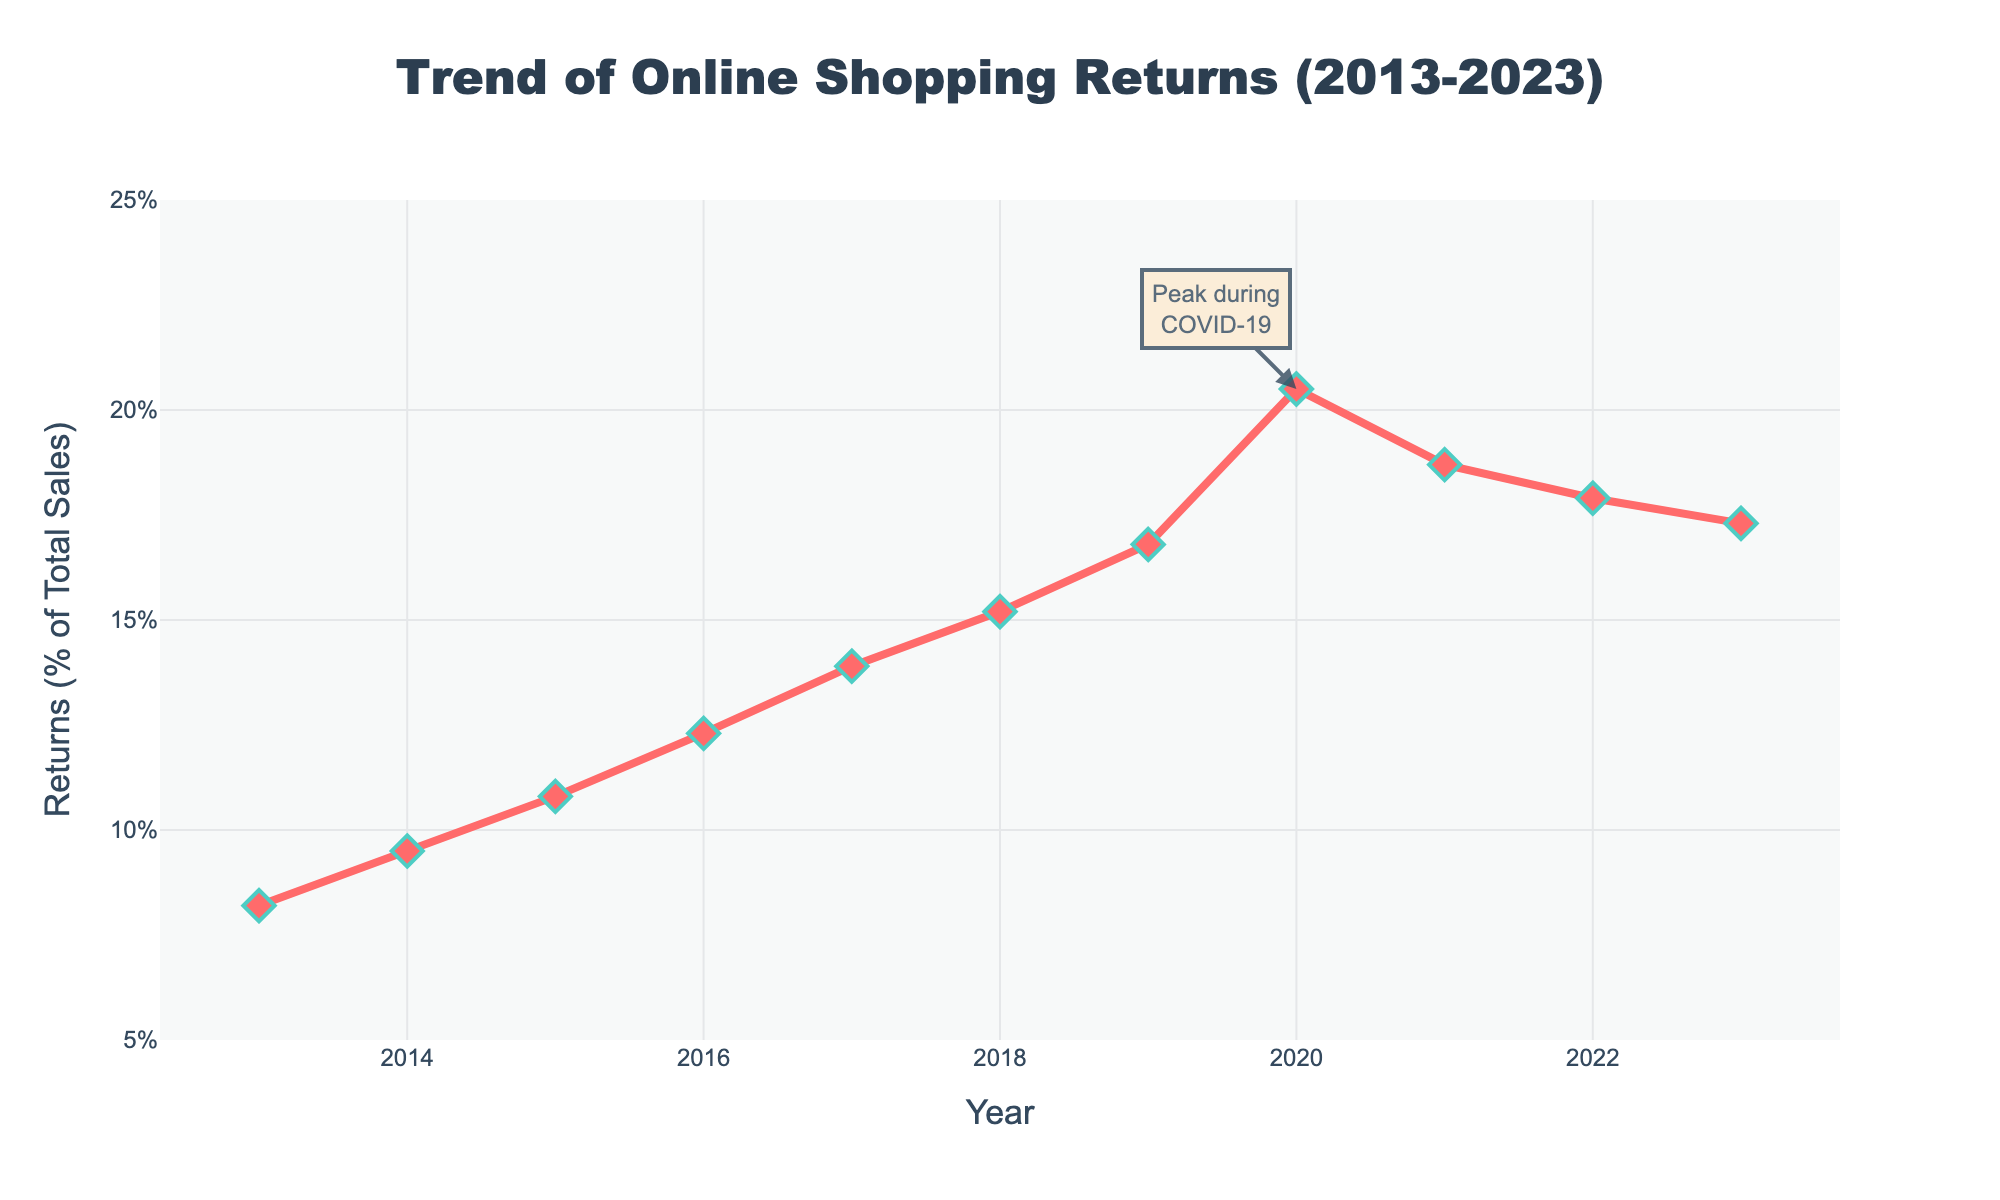What is the percentage increase in online shopping returns from 2013 to 2020? The percentage in 2013 is 8.2%, and in 2020 it is 20.5%. The increase is 20.5% - 8.2% = 12.3%.
Answer: 12.3% Which year had the highest percentage of online shopping returns? The peak value is marked at 2020 with a value of 20.5%.
Answer: 2020 By how much did the percentage of online shopping returns decrease from 2020 to 2023? The percentage in 2020 is 20.5%, and in 2023 it is 17.3%. The decrease is 20.5% - 17.3% = 3.2%.
Answer: 3.2% Did the percentage of online shopping returns increase or decrease between 2019 and 2021? In 2019, the percentage is 16.8%, and in 2021 it is 18.7%. This indicates an increase.
Answer: Increase What was the average percentage of online shopping returns from 2013 to 2023? Sum all percentages and divide by the number of years. (8.2 + 9.5 + 10.8 + 12.3 + 13.9 + 15.2 + 16.8 + 20.5 + 18.7 + 17.9 + 17.3) / 11 ≈ 14.68%.
Answer: 14.68% Compare the percentages of online shopping returns for the years with the highest and lowest values. What is the difference? The highest percentage is 20.5% (2020) and the lowest is 8.2% (2013). The difference is 20.5% - 8.2% = 12.3%.
Answer: 12.3% During which period did online shopping returns see the fastest growth? The growth seems steepest between 2018 (15.2%) and 2020 (20.5%). The increase is 20.5% - 15.2% = 5.3%.
Answer: 2018 to 2020 What is the trend of online shopping returns from 2020 to 2023? The trend shows a decrease, going from 20.5% in 2020 to 17.3% in 2023.
Answer: Decreasing How much higher was the peak percentage of online shopping returns compared to the previous year (2019)? The peak in 2020 is 20.5%, and in 2019 it was 16.8%. The difference is 20.5% - 16.8% = 3.7%.
Answer: 3.7% 